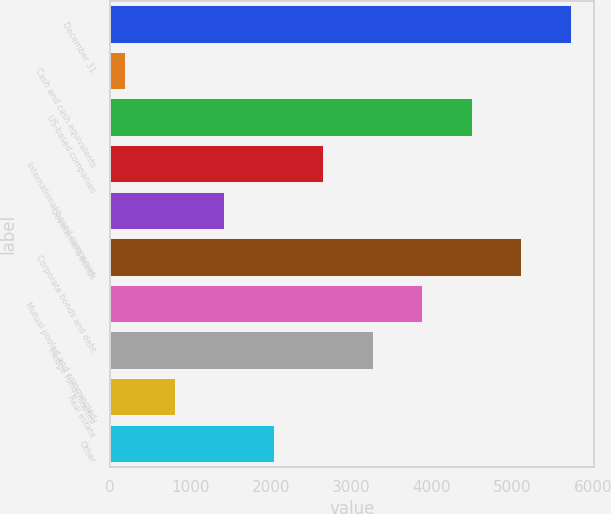Convert chart to OTSL. <chart><loc_0><loc_0><loc_500><loc_500><bar_chart><fcel>December 31<fcel>Cash and cash equivalents<fcel>US-based companies<fcel>International-based companies<fcel>Government bonds<fcel>Corporate bonds and debt<fcel>Mutual pooled and commingled<fcel>Hedge funds/limited<fcel>Real estate<fcel>Other<nl><fcel>5727.3<fcel>186<fcel>4495.9<fcel>2648.8<fcel>1417.4<fcel>5111.6<fcel>3880.2<fcel>3264.5<fcel>801.7<fcel>2033.1<nl></chart> 